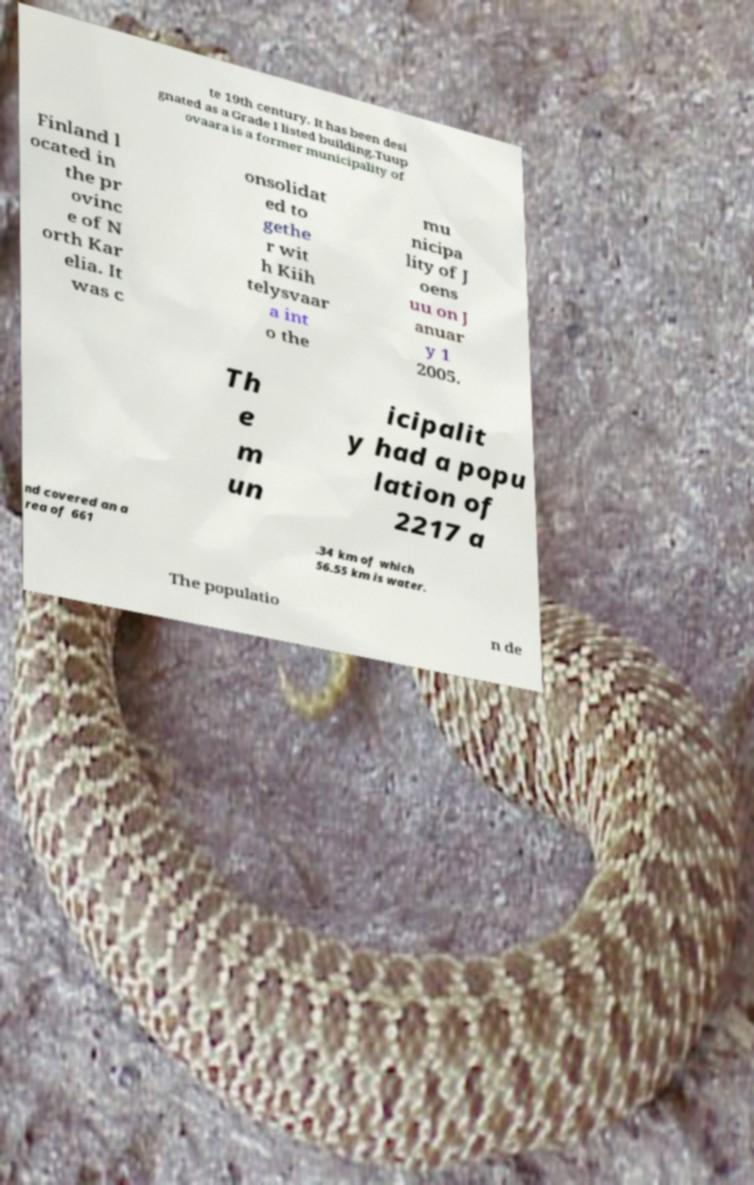I need the written content from this picture converted into text. Can you do that? te 19th century. It has been desi gnated as a Grade I listed building.Tuup ovaara is a former municipality of Finland l ocated in the pr ovinc e of N orth Kar elia. It was c onsolidat ed to gethe r wit h Kiih telysvaar a int o the mu nicipa lity of J oens uu on J anuar y 1 2005. Th e m un icipalit y had a popu lation of 2217 a nd covered an a rea of 661 .34 km of which 56.55 km is water. The populatio n de 